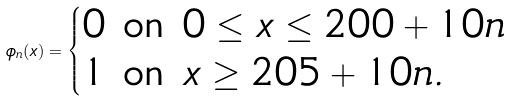<formula> <loc_0><loc_0><loc_500><loc_500>\phi _ { n } ( x ) = \begin{cases} 0 \text { on } 0 \leq x \leq 2 0 0 + 1 0 n \\ 1 \text { on } x \geq 2 0 5 + 1 0 n . \end{cases}</formula> 